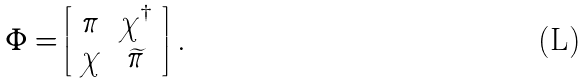<formula> <loc_0><loc_0><loc_500><loc_500>\Phi = \left [ \begin{array} { c c } \pi & \chi ^ { \dagger } \\ \chi & \widetilde { \pi } \end{array} \right ] \, .</formula> 